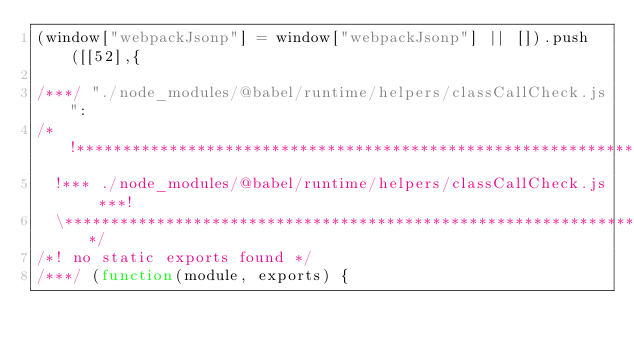<code> <loc_0><loc_0><loc_500><loc_500><_JavaScript_>(window["webpackJsonp"] = window["webpackJsonp"] || []).push([[52],{

/***/ "./node_modules/@babel/runtime/helpers/classCallCheck.js":
/*!***************************************************************!*\
  !*** ./node_modules/@babel/runtime/helpers/classCallCheck.js ***!
  \***************************************************************/
/*! no static exports found */
/***/ (function(module, exports) {
</code> 